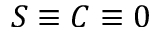Convert formula to latex. <formula><loc_0><loc_0><loc_500><loc_500>S \equiv C \equiv 0</formula> 